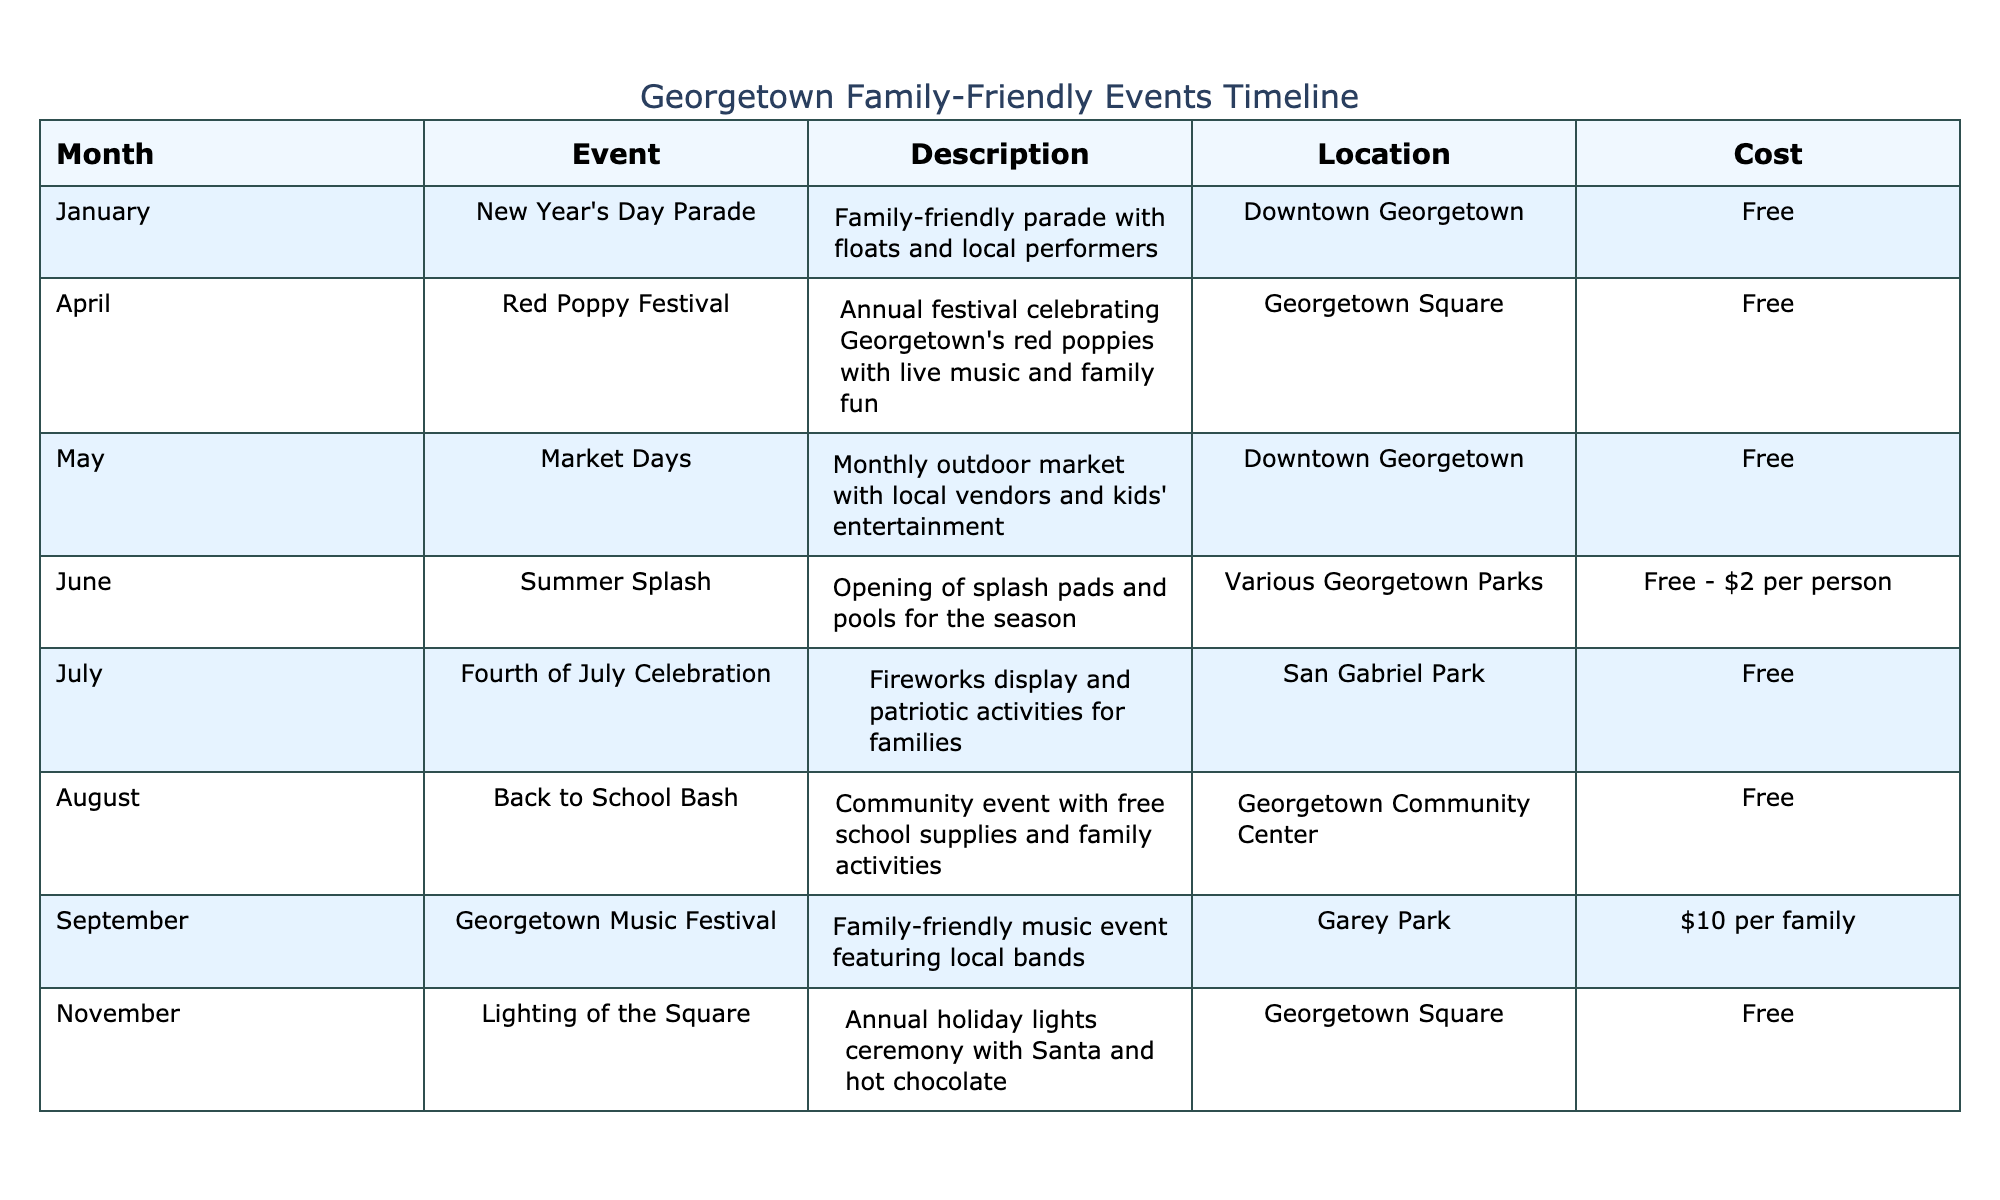What event occurs in April? According to the table, the event listed for April is the Red Poppy Festival.
Answer: Red Poppy Festival Is the Fourth of July Celebration free? The cost column in the table specifies that the Fourth of July Celebration is free.
Answer: Yes What is the location for the Summer Splash event? By looking at the location column in the table, the Summer Splash event takes place at Various Georgetown Parks.
Answer: Various Georgetown Parks How many events are free to attend in July? The table lists only one event in July, which is the Fourth of July Celebration, and it is free. Therefore, the count of free events in July is one.
Answer: 1 What is the average cost of family-friendly events for the months listed? The costs are categorized as: Free (count=5), Free-$2 (average=1), and $10. To compute the average, we sum these costs as (0*5 + 1 + 10) = 11 and divide by the number of events (7), resulting in an average cost of approximately 1.57.
Answer: 1.57 Is there a music festival in Georgetown? Referring to the event descriptions in the table, there is a Georgetown Music Festival listed under September, confirming the presence of a music festival.
Answer: Yes How many total family-friendly events are listed in the table? Counting the unique events in the table, we find a total of 8 family-friendly events across different months.
Answer: 8 Which month has a community event for back-to-school supplies? The table states that the Back to School Bash takes place in August, which is focused on providing school supplies and family activities.
Answer: August 